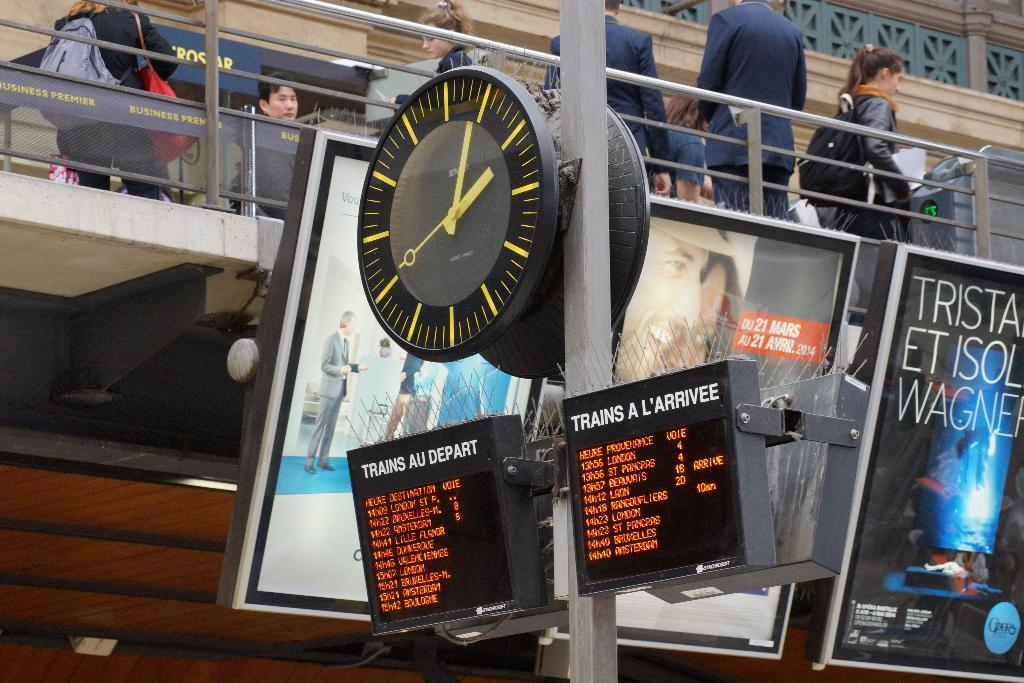<image>
Share a concise interpretation of the image provided. A train station with a lit up sign that says TRAIN A L'ARRIVEE and the train arrival times under it. 